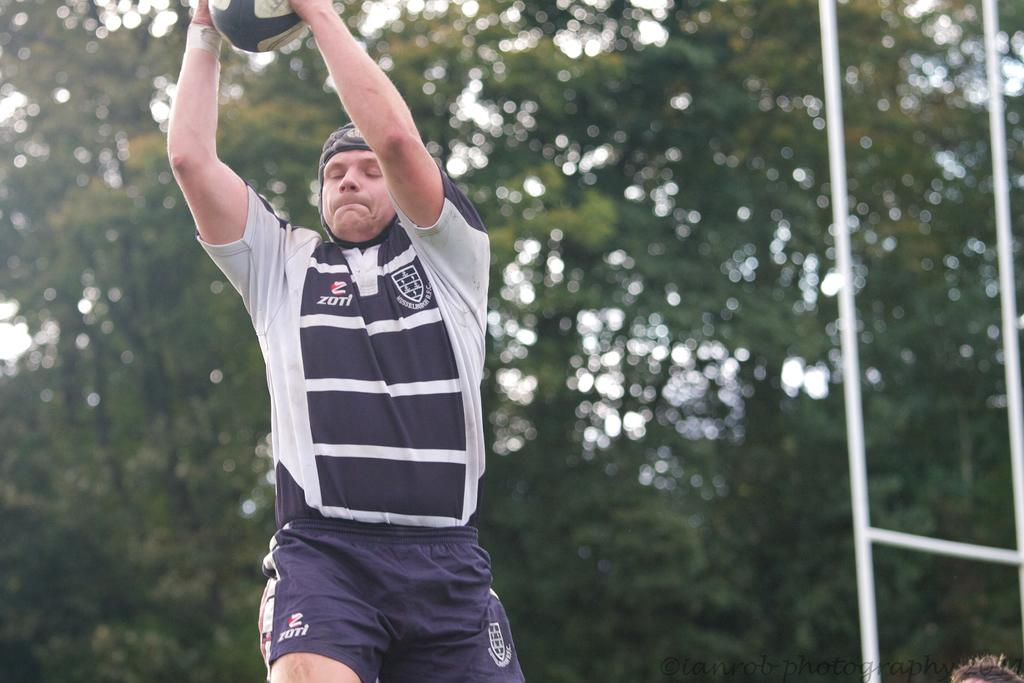<image>
Provide a brief description of the given image. An athlete is wearing a blue and white Zuti shirt and shorts. 